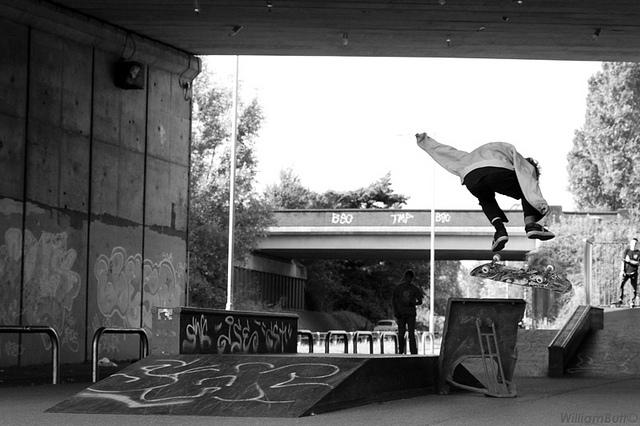How many graffiti pictures are on the overpass wall?

Choices:
A) one
B) two
C) four
D) three three 